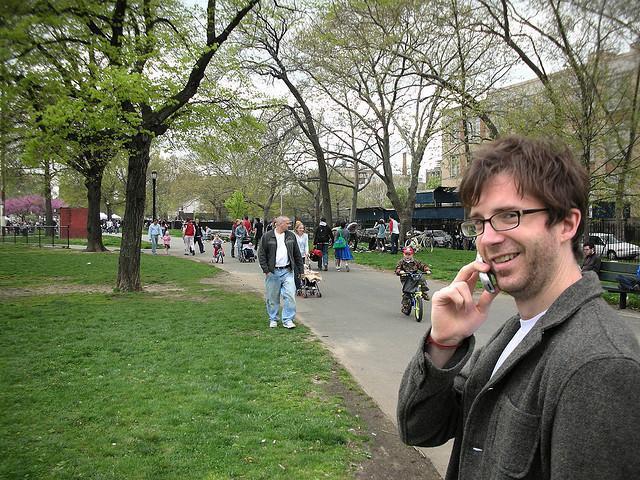How many people are visible?
Give a very brief answer. 3. How many orange balloons are in the picture?
Give a very brief answer. 0. 